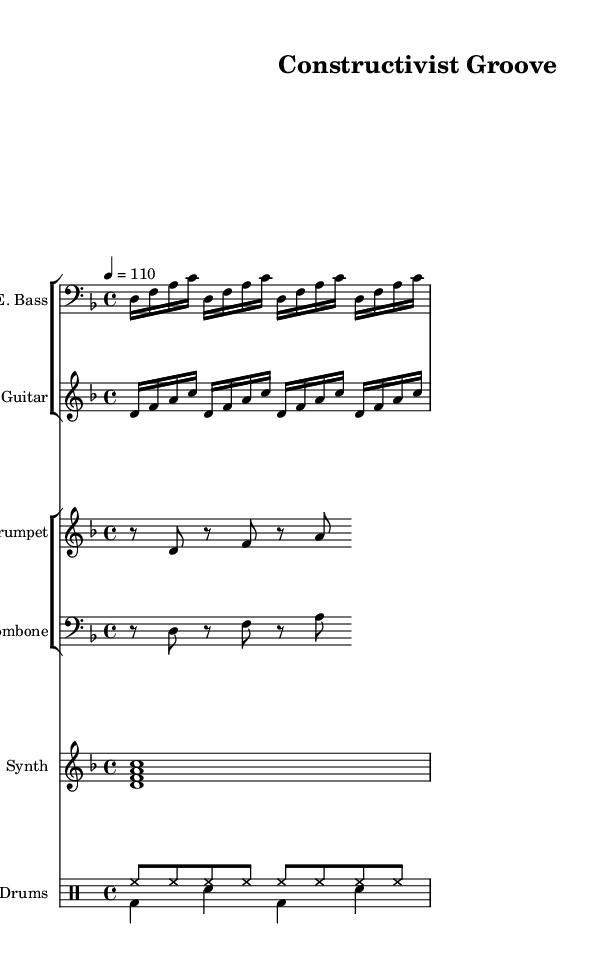What is the key signature of this music? The key signature indicated in the sheet music is D minor, which has one flat. This can be identified by looking at the key signature notation at the beginning of the staff.
Answer: D minor What is the time signature of this music? The time signature is 4/4, which means there are four beats in a measure and a quarter note gets one beat. This is shown at the beginning of the score.
Answer: 4/4 What is the tempo marking for this composition? The tempo marking provided is quarter note = 110, which indicates the speed of the music. This is explicitly stated above the staff in the score.
Answer: 110 How many measures does the electric bass part repeat? The electric bass part repeats for 4 measures, as indicated by the repeat sign at the start of the section. This tells us to play the same notation multiple times.
Answer: 4 Which instruments are included in the brass section? The instruments in the brass section are trumpet and trombone, as identified by the respective staff labels in the score.
Answer: Trumpet, Trombone What is the primary rhythmic pattern for the drums in this piece? The primary rhythmic pattern for the drums consists of alternating bass drum and snare drum in a straightforward two-beat cycle, as indicated in the drum notation. This shows how the drums maintain the funk groove.
Answer: Bass drum and snare drum Identify the synthesizer chord used in the piece. The synthesizer chord played is a D minor chord, consisting of the notes D, F, A, and C. This can be inferred from the chord indicators notated in the synthesizer staff.
Answer: D, F, A, C 